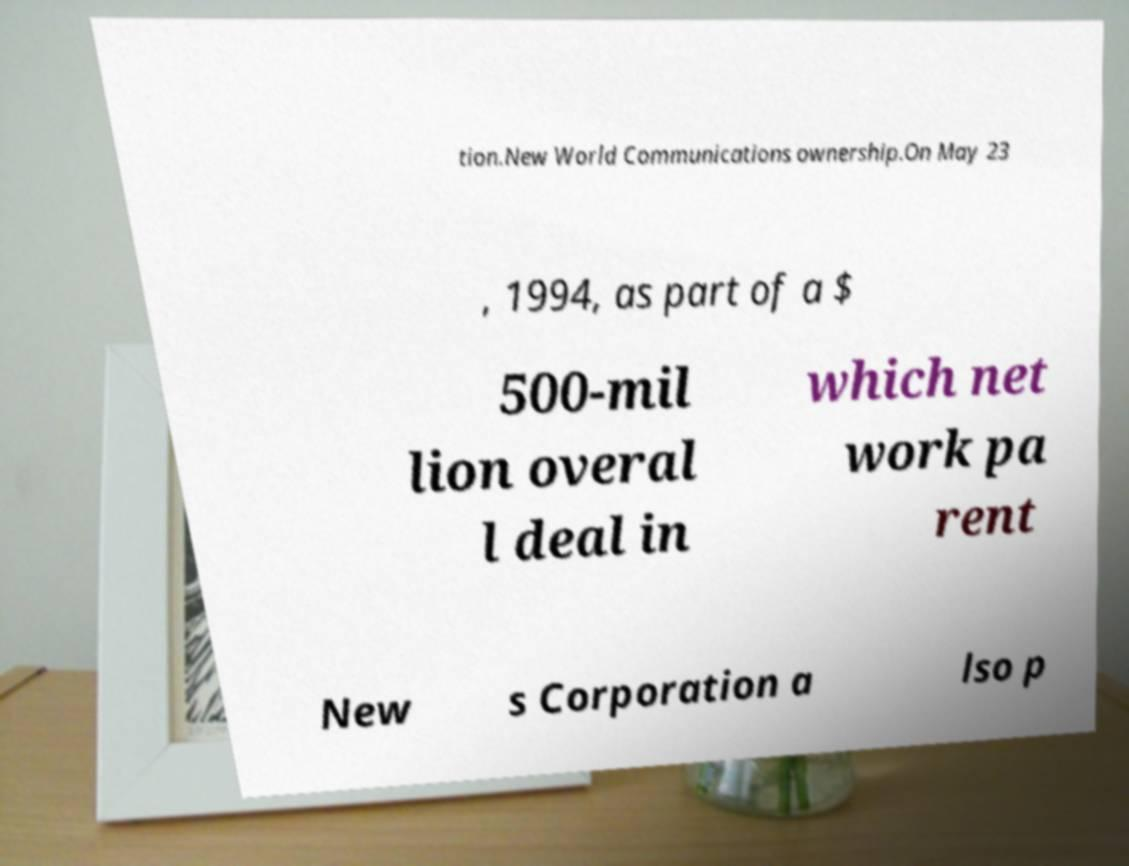Please identify and transcribe the text found in this image. tion.New World Communications ownership.On May 23 , 1994, as part of a $ 500-mil lion overal l deal in which net work pa rent New s Corporation a lso p 